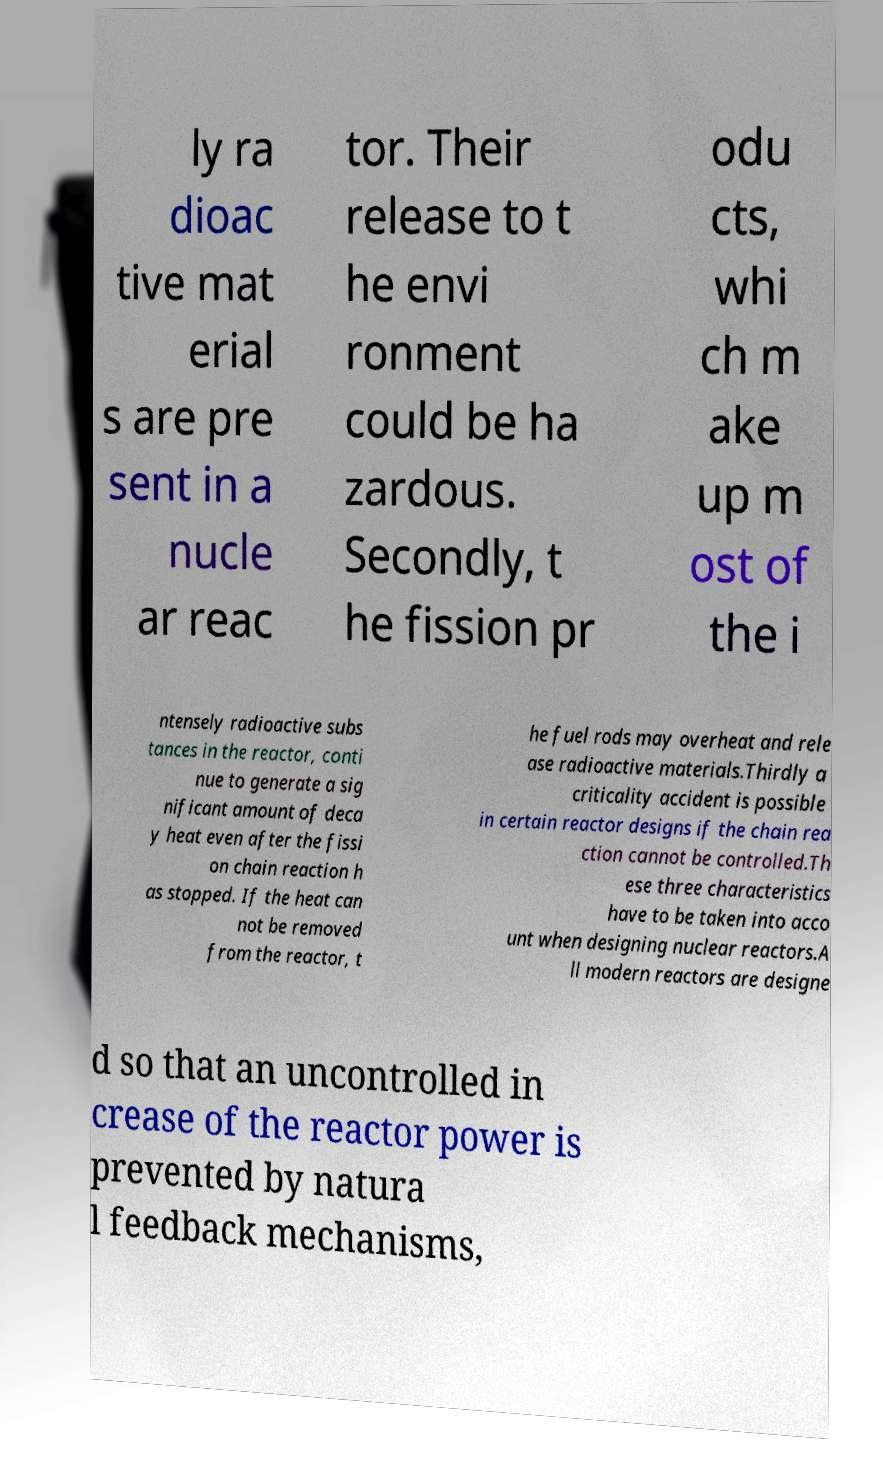There's text embedded in this image that I need extracted. Can you transcribe it verbatim? ly ra dioac tive mat erial s are pre sent in a nucle ar reac tor. Their release to t he envi ronment could be ha zardous. Secondly, t he fission pr odu cts, whi ch m ake up m ost of the i ntensely radioactive subs tances in the reactor, conti nue to generate a sig nificant amount of deca y heat even after the fissi on chain reaction h as stopped. If the heat can not be removed from the reactor, t he fuel rods may overheat and rele ase radioactive materials.Thirdly a criticality accident is possible in certain reactor designs if the chain rea ction cannot be controlled.Th ese three characteristics have to be taken into acco unt when designing nuclear reactors.A ll modern reactors are designe d so that an uncontrolled in crease of the reactor power is prevented by natura l feedback mechanisms, 